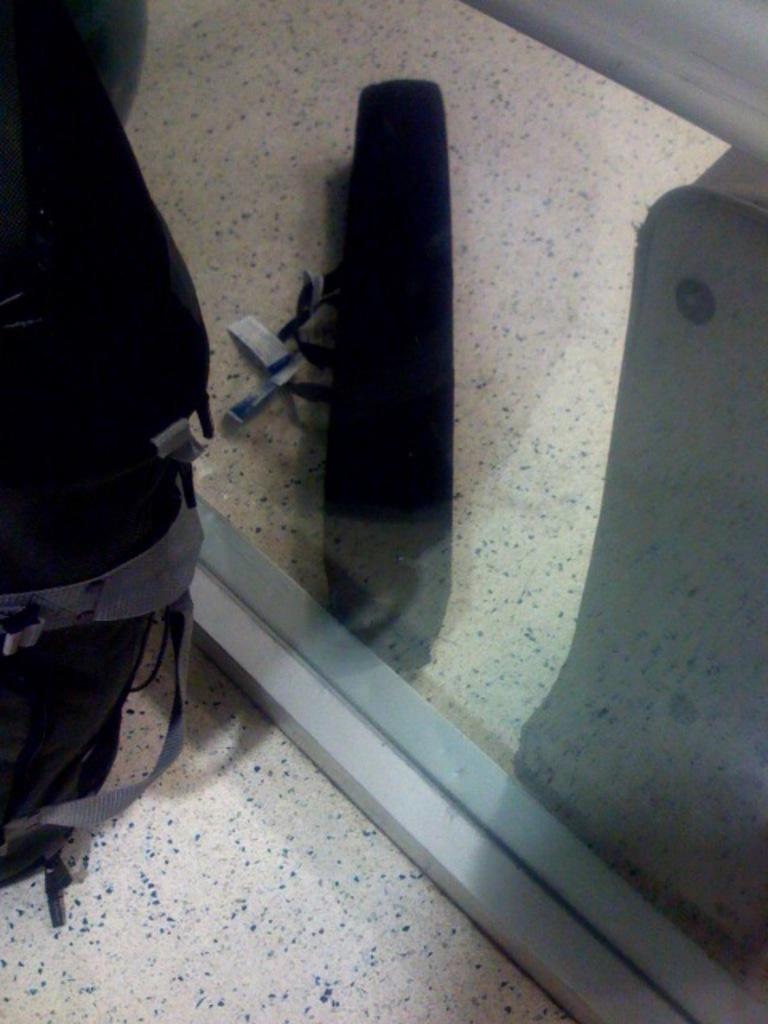Could you give a brief overview of what you see in this image? In this picture we can see a bag on the floor, glass and from glass we can see an object. 